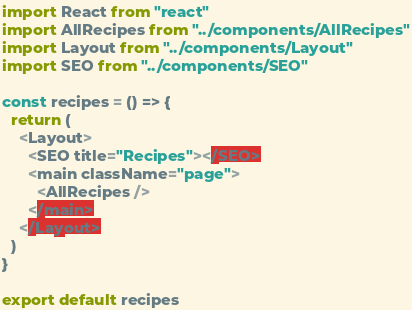Convert code to text. <code><loc_0><loc_0><loc_500><loc_500><_JavaScript_>import React from "react"
import AllRecipes from "../components/AllRecipes"
import Layout from "../components/Layout"
import SEO from "../components/SEO"

const recipes = () => {
  return (
    <Layout>
      <SEO title="Recipes"></SEO>
      <main className="page">
        <AllRecipes />
      </main>
    </Layout>
  )
}

export default recipes
</code> 